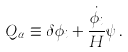Convert formula to latex. <formula><loc_0><loc_0><loc_500><loc_500>Q _ { \alpha } \equiv \delta \phi _ { i } + \frac { \dot { \phi } _ { i } } { H } \psi \, .</formula> 